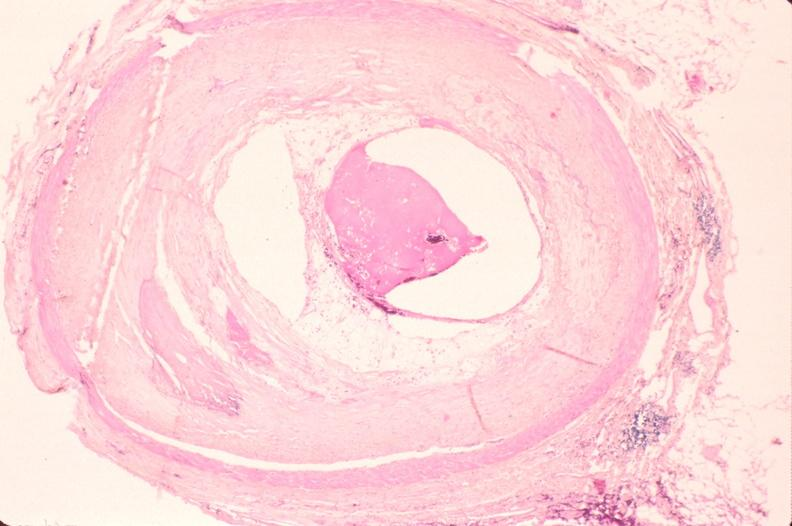does this image show atherosclerosis?
Answer the question using a single word or phrase. Yes 